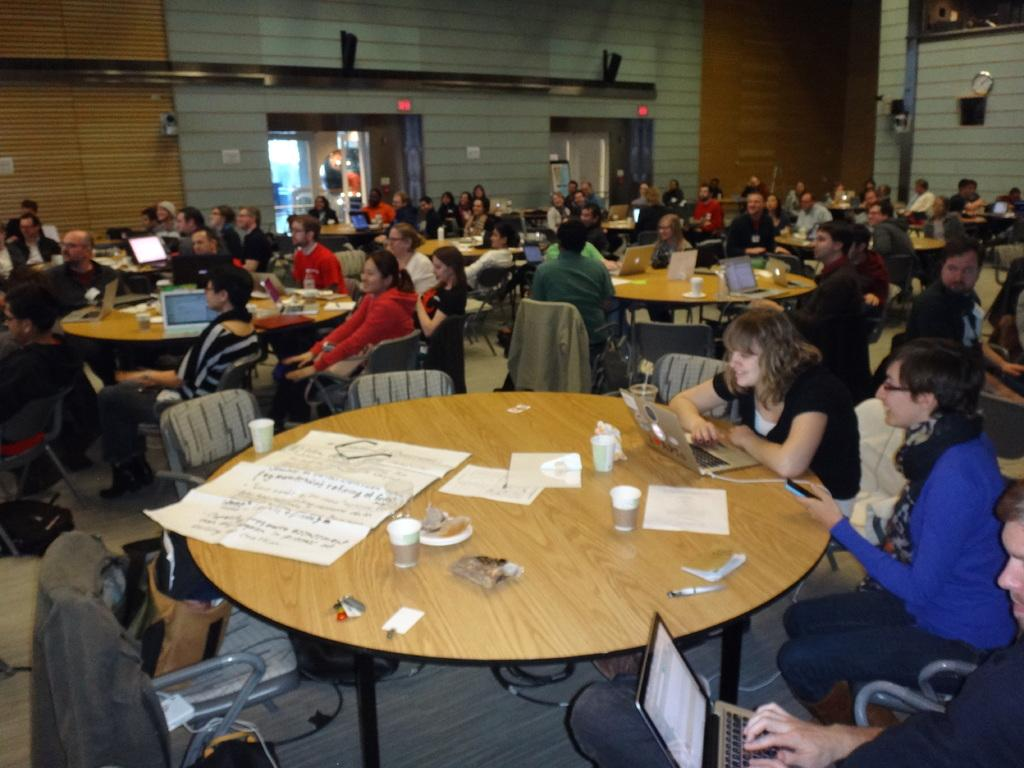How many people are the persons are in the image? There is a group of persons in the image. What are the persons doing in the image? The persons are sitting around tables. What type of furniture is visible in the image? There is no specific furniture mentioned in the provided facts, so it cannot be determined from the image. 